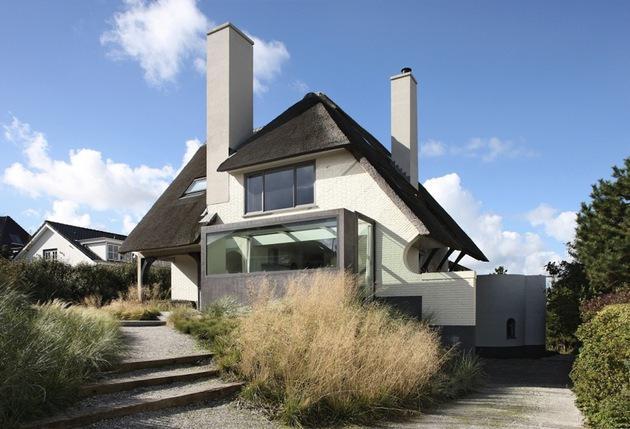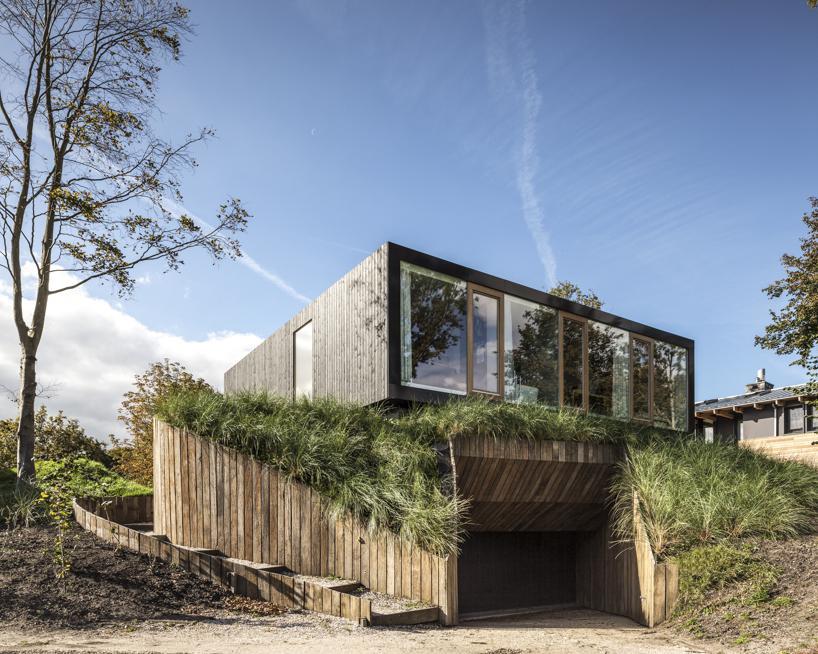The first image is the image on the left, the second image is the image on the right. Examine the images to the left and right. Is the description "One of the homes has a flat roof and the other has angular roof lines." accurate? Answer yes or no. Yes. The first image is the image on the left, the second image is the image on the right. Examine the images to the left and right. Is the description "A mid century modern house has a flat roof." accurate? Answer yes or no. Yes. 